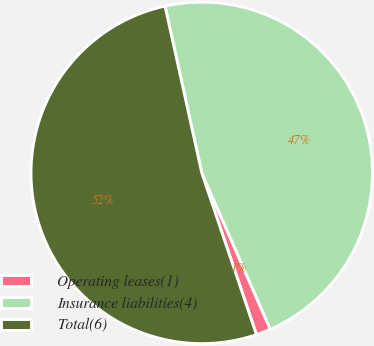Convert chart. <chart><loc_0><loc_0><loc_500><loc_500><pie_chart><fcel>Operating leases(1)<fcel>Insurance liabilities(4)<fcel>Total(6)<nl><fcel>1.39%<fcel>46.87%<fcel>51.73%<nl></chart> 